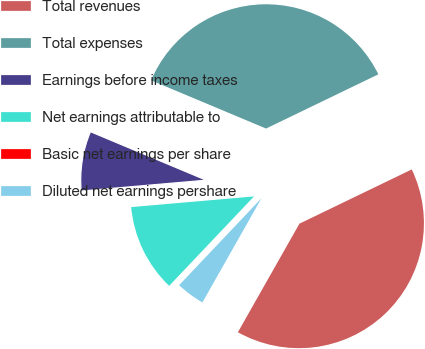Convert chart. <chart><loc_0><loc_0><loc_500><loc_500><pie_chart><fcel>Total revenues<fcel>Total expenses<fcel>Earnings before income taxes<fcel>Net earnings attributable to<fcel>Basic net earnings per share<fcel>Diluted net earnings pershare<nl><fcel>40.37%<fcel>36.52%<fcel>7.7%<fcel>11.54%<fcel>0.01%<fcel>3.86%<nl></chart> 